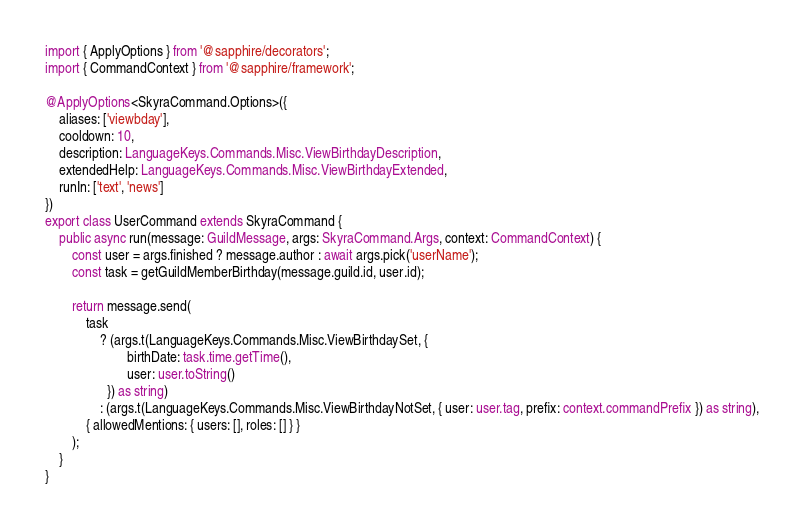<code> <loc_0><loc_0><loc_500><loc_500><_TypeScript_>import { ApplyOptions } from '@sapphire/decorators';
import { CommandContext } from '@sapphire/framework';

@ApplyOptions<SkyraCommand.Options>({
	aliases: ['viewbday'],
	cooldown: 10,
	description: LanguageKeys.Commands.Misc.ViewBirthdayDescription,
	extendedHelp: LanguageKeys.Commands.Misc.ViewBirthdayExtended,
	runIn: ['text', 'news']
})
export class UserCommand extends SkyraCommand {
	public async run(message: GuildMessage, args: SkyraCommand.Args, context: CommandContext) {
		const user = args.finished ? message.author : await args.pick('userName');
		const task = getGuildMemberBirthday(message.guild.id, user.id);

		return message.send(
			task
				? (args.t(LanguageKeys.Commands.Misc.ViewBirthdaySet, {
						birthDate: task.time.getTime(),
						user: user.toString()
				  }) as string)
				: (args.t(LanguageKeys.Commands.Misc.ViewBirthdayNotSet, { user: user.tag, prefix: context.commandPrefix }) as string),
			{ allowedMentions: { users: [], roles: [] } }
		);
	}
}
</code> 